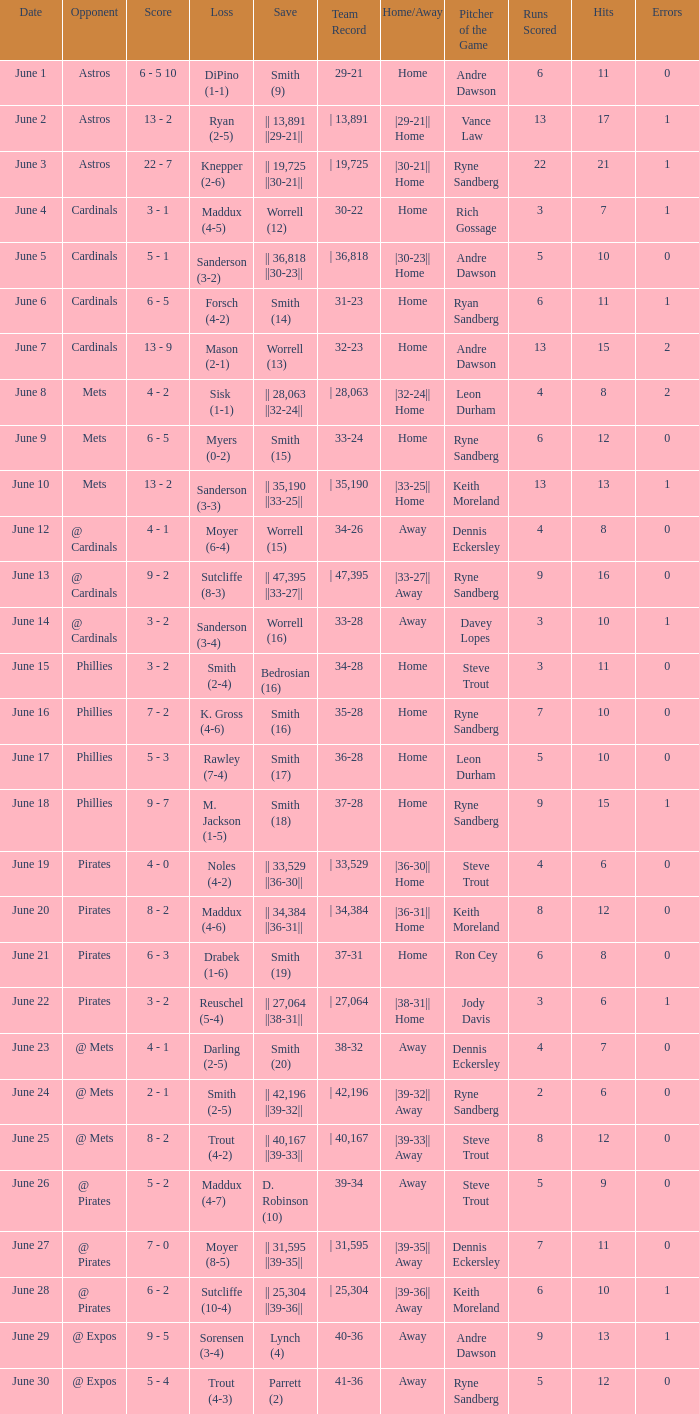Give me the full table as a dictionary. {'header': ['Date', 'Opponent', 'Score', 'Loss', 'Save', 'Team Record', 'Home/Away', 'Pitcher of the Game', 'Runs Scored', 'Hits', 'Errors'], 'rows': [['June 1', 'Astros', '6 - 5 10', 'DiPino (1-1)', 'Smith (9)', '29-21', 'Home', 'Andre Dawson', '6', '11', '0'], ['June 2', 'Astros', '13 - 2', 'Ryan (2-5)', '|| 13,891 ||29-21||', '| 13,891', '|29-21|| Home', 'Vance Law', '13', '17', '1'], ['June 3', 'Astros', '22 - 7', 'Knepper (2-6)', '|| 19,725 ||30-21||', '| 19,725', '|30-21|| Home', 'Ryne Sandberg', '22', '21', '1'], ['June 4', 'Cardinals', '3 - 1', 'Maddux (4-5)', 'Worrell (12)', '30-22', 'Home', 'Rich Gossage', '3', '7', '1'], ['June 5', 'Cardinals', '5 - 1', 'Sanderson (3-2)', '|| 36,818 ||30-23||', '| 36,818', '|30-23|| Home', 'Andre Dawson', '5', '10', '0'], ['June 6', 'Cardinals', '6 - 5', 'Forsch (4-2)', 'Smith (14)', '31-23', 'Home', 'Ryan Sandberg', '6', '11', '1'], ['June 7', 'Cardinals', '13 - 9', 'Mason (2-1)', 'Worrell (13)', '32-23', 'Home', 'Andre Dawson', '13', '15', '2'], ['June 8', 'Mets', '4 - 2', 'Sisk (1-1)', '|| 28,063 ||32-24||', '| 28,063', '|32-24|| Home', 'Leon Durham', '4', '8', '2'], ['June 9', 'Mets', '6 - 5', 'Myers (0-2)', 'Smith (15)', '33-24', 'Home', 'Ryne Sandberg', '6', '12', '0'], ['June 10', 'Mets', '13 - 2', 'Sanderson (3-3)', '|| 35,190 ||33-25||', '| 35,190', '|33-25|| Home', 'Keith Moreland', '13', '13', '1'], ['June 12', '@ Cardinals', '4 - 1', 'Moyer (6-4)', 'Worrell (15)', '34-26', 'Away', 'Dennis Eckersley', '4', '8', '0'], ['June 13', '@ Cardinals', '9 - 2', 'Sutcliffe (8-3)', '|| 47,395 ||33-27||', '| 47,395', '|33-27|| Away', 'Ryne Sandberg', '9', '16', '0'], ['June 14', '@ Cardinals', '3 - 2', 'Sanderson (3-4)', 'Worrell (16)', '33-28', 'Away', 'Davey Lopes', '3', '10', '1'], ['June 15', 'Phillies', '3 - 2', 'Smith (2-4)', 'Bedrosian (16)', '34-28', 'Home', 'Steve Trout', '3', '11', '0'], ['June 16', 'Phillies', '7 - 2', 'K. Gross (4-6)', 'Smith (16)', '35-28', 'Home', 'Ryne Sandberg', '7', '10', '0'], ['June 17', 'Phillies', '5 - 3', 'Rawley (7-4)', 'Smith (17)', '36-28', 'Home', 'Leon Durham', '5', '10', '0'], ['June 18', 'Phillies', '9 - 7', 'M. Jackson (1-5)', 'Smith (18)', '37-28', 'Home', 'Ryne Sandberg', '9', '15', '1'], ['June 19', 'Pirates', '4 - 0', 'Noles (4-2)', '|| 33,529 ||36-30||', '| 33,529', '|36-30|| Home', 'Steve Trout', '4', '6', '0'], ['June 20', 'Pirates', '8 - 2', 'Maddux (4-6)', '|| 34,384 ||36-31||', '| 34,384', '|36-31|| Home', 'Keith Moreland', '8', '12', '0'], ['June 21', 'Pirates', '6 - 3', 'Drabek (1-6)', 'Smith (19)', '37-31', 'Home', 'Ron Cey', '6', '8', '0'], ['June 22', 'Pirates', '3 - 2', 'Reuschel (5-4)', '|| 27,064 ||38-31||', '| 27,064', '|38-31|| Home', 'Jody Davis', '3', '6', '1'], ['June 23', '@ Mets', '4 - 1', 'Darling (2-5)', 'Smith (20)', '38-32', 'Away', 'Dennis Eckersley', '4', '7', '0'], ['June 24', '@ Mets', '2 - 1', 'Smith (2-5)', '|| 42,196 ||39-32||', '| 42,196', '|39-32|| Away', 'Ryne Sandberg', '2', '6', '0'], ['June 25', '@ Mets', '8 - 2', 'Trout (4-2)', '|| 40,167 ||39-33||', '| 40,167', '|39-33|| Away', 'Steve Trout', '8', '12', '0'], ['June 26', '@ Pirates', '5 - 2', 'Maddux (4-7)', 'D. Robinson (10)', '39-34', 'Away', 'Steve Trout', '5', '9', '0'], ['June 27', '@ Pirates', '7 - 0', 'Moyer (8-5)', '|| 31,595 ||39-35||', '| 31,595', '|39-35|| Away', 'Dennis Eckersley', '7', '11', '0'], ['June 28', '@ Pirates', '6 - 2', 'Sutcliffe (10-4)', '|| 25,304 ||39-36||', '| 25,304', '|39-36|| Away', 'Keith Moreland', '6', '10', '1'], ['June 29', '@ Expos', '9 - 5', 'Sorensen (3-4)', 'Lynch (4)', '40-36', 'Away', 'Andre Dawson', '9', '13', '1'], ['June 30', '@ Expos', '5 - 4', 'Trout (4-3)', 'Parrett (2)', '41-36', 'Away', 'Ryne Sandberg', '5', '12', '0']]} What is the date for the game that included a loss of sutcliffe (10-4)? June 28. 